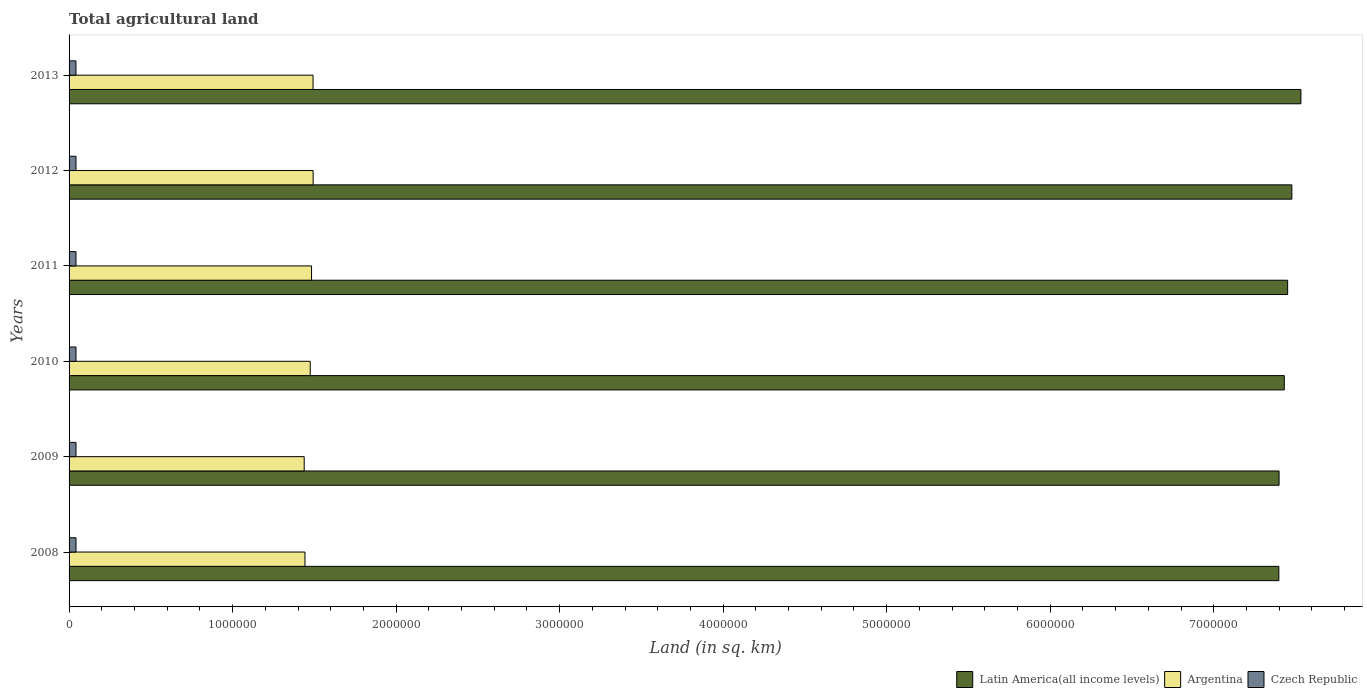How many bars are there on the 2nd tick from the bottom?
Offer a very short reply. 3. What is the label of the 6th group of bars from the top?
Give a very brief answer. 2008. What is the total agricultural land in Latin America(all income levels) in 2012?
Give a very brief answer. 7.48e+06. Across all years, what is the maximum total agricultural land in Argentina?
Provide a succinct answer. 1.49e+06. Across all years, what is the minimum total agricultural land in Latin America(all income levels)?
Ensure brevity in your answer.  7.40e+06. In which year was the total agricultural land in Argentina minimum?
Ensure brevity in your answer.  2009. What is the total total agricultural land in Argentina in the graph?
Offer a very short reply. 8.82e+06. What is the difference between the total agricultural land in Latin America(all income levels) in 2011 and that in 2012?
Give a very brief answer. -2.57e+04. What is the difference between the total agricultural land in Argentina in 2011 and the total agricultural land in Czech Republic in 2012?
Your answer should be very brief. 1.44e+06. What is the average total agricultural land in Latin America(all income levels) per year?
Provide a succinct answer. 7.45e+06. In the year 2008, what is the difference between the total agricultural land in Latin America(all income levels) and total agricultural land in Czech Republic?
Make the answer very short. 7.36e+06. In how many years, is the total agricultural land in Latin America(all income levels) greater than 4400000 sq.km?
Make the answer very short. 6. What is the ratio of the total agricultural land in Latin America(all income levels) in 2009 to that in 2010?
Ensure brevity in your answer.  1. What is the difference between the highest and the second highest total agricultural land in Latin America(all income levels)?
Your response must be concise. 5.54e+04. What is the difference between the highest and the lowest total agricultural land in Argentina?
Your answer should be compact. 5.46e+04. Is the sum of the total agricultural land in Latin America(all income levels) in 2009 and 2011 greater than the maximum total agricultural land in Argentina across all years?
Your response must be concise. Yes. What does the 3rd bar from the top in 2010 represents?
Provide a short and direct response. Latin America(all income levels). What does the 1st bar from the bottom in 2008 represents?
Provide a short and direct response. Latin America(all income levels). Is it the case that in every year, the sum of the total agricultural land in Czech Republic and total agricultural land in Latin America(all income levels) is greater than the total agricultural land in Argentina?
Your answer should be very brief. Yes. Are the values on the major ticks of X-axis written in scientific E-notation?
Keep it short and to the point. No. Does the graph contain grids?
Provide a short and direct response. No. Where does the legend appear in the graph?
Your response must be concise. Bottom right. How many legend labels are there?
Offer a very short reply. 3. How are the legend labels stacked?
Your answer should be compact. Horizontal. What is the title of the graph?
Offer a very short reply. Total agricultural land. Does "Ghana" appear as one of the legend labels in the graph?
Offer a very short reply. No. What is the label or title of the X-axis?
Ensure brevity in your answer.  Land (in sq. km). What is the label or title of the Y-axis?
Make the answer very short. Years. What is the Land (in sq. km) in Latin America(all income levels) in 2008?
Your answer should be very brief. 7.40e+06. What is the Land (in sq. km) of Argentina in 2008?
Make the answer very short. 1.44e+06. What is the Land (in sq. km) of Czech Republic in 2008?
Offer a very short reply. 4.24e+04. What is the Land (in sq. km) of Latin America(all income levels) in 2009?
Offer a very short reply. 7.40e+06. What is the Land (in sq. km) of Argentina in 2009?
Make the answer very short. 1.44e+06. What is the Land (in sq. km) in Czech Republic in 2009?
Your answer should be compact. 4.24e+04. What is the Land (in sq. km) in Latin America(all income levels) in 2010?
Offer a very short reply. 7.43e+06. What is the Land (in sq. km) of Argentina in 2010?
Offer a terse response. 1.47e+06. What is the Land (in sq. km) of Czech Republic in 2010?
Offer a very short reply. 4.23e+04. What is the Land (in sq. km) in Latin America(all income levels) in 2011?
Give a very brief answer. 7.45e+06. What is the Land (in sq. km) in Argentina in 2011?
Make the answer very short. 1.48e+06. What is the Land (in sq. km) of Czech Republic in 2011?
Give a very brief answer. 4.23e+04. What is the Land (in sq. km) in Latin America(all income levels) in 2012?
Offer a very short reply. 7.48e+06. What is the Land (in sq. km) in Argentina in 2012?
Offer a very short reply. 1.49e+06. What is the Land (in sq. km) in Czech Republic in 2012?
Provide a succinct answer. 4.22e+04. What is the Land (in sq. km) in Latin America(all income levels) in 2013?
Offer a very short reply. 7.53e+06. What is the Land (in sq. km) of Argentina in 2013?
Ensure brevity in your answer.  1.49e+06. What is the Land (in sq. km) in Czech Republic in 2013?
Your response must be concise. 4.22e+04. Across all years, what is the maximum Land (in sq. km) of Latin America(all income levels)?
Your response must be concise. 7.53e+06. Across all years, what is the maximum Land (in sq. km) of Argentina?
Offer a terse response. 1.49e+06. Across all years, what is the maximum Land (in sq. km) of Czech Republic?
Provide a succinct answer. 4.24e+04. Across all years, what is the minimum Land (in sq. km) of Latin America(all income levels)?
Keep it short and to the point. 7.40e+06. Across all years, what is the minimum Land (in sq. km) of Argentina?
Your answer should be very brief. 1.44e+06. Across all years, what is the minimum Land (in sq. km) in Czech Republic?
Provide a succinct answer. 4.22e+04. What is the total Land (in sq. km) in Latin America(all income levels) in the graph?
Your answer should be very brief. 4.47e+07. What is the total Land (in sq. km) in Argentina in the graph?
Make the answer very short. 8.82e+06. What is the total Land (in sq. km) in Czech Republic in the graph?
Keep it short and to the point. 2.54e+05. What is the difference between the Land (in sq. km) of Latin America(all income levels) in 2008 and that in 2009?
Ensure brevity in your answer.  -1397.7. What is the difference between the Land (in sq. km) of Argentina in 2008 and that in 2009?
Make the answer very short. 4690. What is the difference between the Land (in sq. km) of Czech Republic in 2008 and that in 2009?
Provide a short and direct response. 50. What is the difference between the Land (in sq. km) of Latin America(all income levels) in 2008 and that in 2010?
Offer a very short reply. -3.33e+04. What is the difference between the Land (in sq. km) of Argentina in 2008 and that in 2010?
Provide a succinct answer. -3.22e+04. What is the difference between the Land (in sq. km) in Latin America(all income levels) in 2008 and that in 2011?
Your answer should be compact. -5.38e+04. What is the difference between the Land (in sq. km) in Argentina in 2008 and that in 2011?
Provide a short and direct response. -4.02e+04. What is the difference between the Land (in sq. km) of Czech Republic in 2008 and that in 2011?
Your answer should be compact. 150. What is the difference between the Land (in sq. km) in Latin America(all income levels) in 2008 and that in 2012?
Offer a terse response. -7.95e+04. What is the difference between the Land (in sq. km) in Argentina in 2008 and that in 2012?
Your answer should be very brief. -4.99e+04. What is the difference between the Land (in sq. km) in Czech Republic in 2008 and that in 2012?
Your answer should be compact. 190. What is the difference between the Land (in sq. km) in Latin America(all income levels) in 2008 and that in 2013?
Provide a succinct answer. -1.35e+05. What is the difference between the Land (in sq. km) in Argentina in 2008 and that in 2013?
Your answer should be compact. -4.94e+04. What is the difference between the Land (in sq. km) of Czech Republic in 2008 and that in 2013?
Your answer should be very brief. 250. What is the difference between the Land (in sq. km) in Latin America(all income levels) in 2009 and that in 2010?
Give a very brief answer. -3.19e+04. What is the difference between the Land (in sq. km) in Argentina in 2009 and that in 2010?
Your answer should be compact. -3.69e+04. What is the difference between the Land (in sq. km) of Latin America(all income levels) in 2009 and that in 2011?
Provide a short and direct response. -5.24e+04. What is the difference between the Land (in sq. km) in Argentina in 2009 and that in 2011?
Give a very brief answer. -4.49e+04. What is the difference between the Land (in sq. km) of Czech Republic in 2009 and that in 2011?
Provide a short and direct response. 100. What is the difference between the Land (in sq. km) in Latin America(all income levels) in 2009 and that in 2012?
Your answer should be compact. -7.81e+04. What is the difference between the Land (in sq. km) of Argentina in 2009 and that in 2012?
Your response must be concise. -5.46e+04. What is the difference between the Land (in sq. km) in Czech Republic in 2009 and that in 2012?
Make the answer very short. 140. What is the difference between the Land (in sq. km) of Latin America(all income levels) in 2009 and that in 2013?
Your answer should be compact. -1.33e+05. What is the difference between the Land (in sq. km) in Argentina in 2009 and that in 2013?
Provide a succinct answer. -5.41e+04. What is the difference between the Land (in sq. km) of Czech Republic in 2009 and that in 2013?
Your answer should be very brief. 200. What is the difference between the Land (in sq. km) in Latin America(all income levels) in 2010 and that in 2011?
Keep it short and to the point. -2.05e+04. What is the difference between the Land (in sq. km) of Argentina in 2010 and that in 2011?
Offer a very short reply. -8000. What is the difference between the Land (in sq. km) of Czech Republic in 2010 and that in 2011?
Provide a short and direct response. 50. What is the difference between the Land (in sq. km) of Latin America(all income levels) in 2010 and that in 2012?
Your answer should be compact. -4.62e+04. What is the difference between the Land (in sq. km) of Argentina in 2010 and that in 2012?
Ensure brevity in your answer.  -1.77e+04. What is the difference between the Land (in sq. km) in Czech Republic in 2010 and that in 2012?
Offer a terse response. 90. What is the difference between the Land (in sq. km) of Latin America(all income levels) in 2010 and that in 2013?
Provide a succinct answer. -1.02e+05. What is the difference between the Land (in sq. km) in Argentina in 2010 and that in 2013?
Your answer should be very brief. -1.72e+04. What is the difference between the Land (in sq. km) of Czech Republic in 2010 and that in 2013?
Your answer should be very brief. 150. What is the difference between the Land (in sq. km) of Latin America(all income levels) in 2011 and that in 2012?
Offer a very short reply. -2.57e+04. What is the difference between the Land (in sq. km) of Argentina in 2011 and that in 2012?
Ensure brevity in your answer.  -9730. What is the difference between the Land (in sq. km) in Latin America(all income levels) in 2011 and that in 2013?
Offer a terse response. -8.11e+04. What is the difference between the Land (in sq. km) of Argentina in 2011 and that in 2013?
Give a very brief answer. -9180. What is the difference between the Land (in sq. km) of Czech Republic in 2011 and that in 2013?
Give a very brief answer. 100. What is the difference between the Land (in sq. km) in Latin America(all income levels) in 2012 and that in 2013?
Make the answer very short. -5.54e+04. What is the difference between the Land (in sq. km) in Argentina in 2012 and that in 2013?
Provide a short and direct response. 550. What is the difference between the Land (in sq. km) of Latin America(all income levels) in 2008 and the Land (in sq. km) of Argentina in 2009?
Offer a terse response. 5.96e+06. What is the difference between the Land (in sq. km) in Latin America(all income levels) in 2008 and the Land (in sq. km) in Czech Republic in 2009?
Give a very brief answer. 7.36e+06. What is the difference between the Land (in sq. km) in Argentina in 2008 and the Land (in sq. km) in Czech Republic in 2009?
Offer a very short reply. 1.40e+06. What is the difference between the Land (in sq. km) in Latin America(all income levels) in 2008 and the Land (in sq. km) in Argentina in 2010?
Your response must be concise. 5.92e+06. What is the difference between the Land (in sq. km) of Latin America(all income levels) in 2008 and the Land (in sq. km) of Czech Republic in 2010?
Provide a succinct answer. 7.36e+06. What is the difference between the Land (in sq. km) in Argentina in 2008 and the Land (in sq. km) in Czech Republic in 2010?
Provide a short and direct response. 1.40e+06. What is the difference between the Land (in sq. km) of Latin America(all income levels) in 2008 and the Land (in sq. km) of Argentina in 2011?
Your answer should be compact. 5.92e+06. What is the difference between the Land (in sq. km) in Latin America(all income levels) in 2008 and the Land (in sq. km) in Czech Republic in 2011?
Your answer should be very brief. 7.36e+06. What is the difference between the Land (in sq. km) in Argentina in 2008 and the Land (in sq. km) in Czech Republic in 2011?
Your answer should be very brief. 1.40e+06. What is the difference between the Land (in sq. km) in Latin America(all income levels) in 2008 and the Land (in sq. km) in Argentina in 2012?
Make the answer very short. 5.91e+06. What is the difference between the Land (in sq. km) of Latin America(all income levels) in 2008 and the Land (in sq. km) of Czech Republic in 2012?
Your response must be concise. 7.36e+06. What is the difference between the Land (in sq. km) of Argentina in 2008 and the Land (in sq. km) of Czech Republic in 2012?
Keep it short and to the point. 1.40e+06. What is the difference between the Land (in sq. km) of Latin America(all income levels) in 2008 and the Land (in sq. km) of Argentina in 2013?
Provide a succinct answer. 5.91e+06. What is the difference between the Land (in sq. km) in Latin America(all income levels) in 2008 and the Land (in sq. km) in Czech Republic in 2013?
Your answer should be compact. 7.36e+06. What is the difference between the Land (in sq. km) in Argentina in 2008 and the Land (in sq. km) in Czech Republic in 2013?
Your answer should be compact. 1.40e+06. What is the difference between the Land (in sq. km) of Latin America(all income levels) in 2009 and the Land (in sq. km) of Argentina in 2010?
Offer a terse response. 5.92e+06. What is the difference between the Land (in sq. km) of Latin America(all income levels) in 2009 and the Land (in sq. km) of Czech Republic in 2010?
Keep it short and to the point. 7.36e+06. What is the difference between the Land (in sq. km) in Argentina in 2009 and the Land (in sq. km) in Czech Republic in 2010?
Make the answer very short. 1.40e+06. What is the difference between the Land (in sq. km) of Latin America(all income levels) in 2009 and the Land (in sq. km) of Argentina in 2011?
Ensure brevity in your answer.  5.92e+06. What is the difference between the Land (in sq. km) in Latin America(all income levels) in 2009 and the Land (in sq. km) in Czech Republic in 2011?
Ensure brevity in your answer.  7.36e+06. What is the difference between the Land (in sq. km) of Argentina in 2009 and the Land (in sq. km) of Czech Republic in 2011?
Your answer should be compact. 1.40e+06. What is the difference between the Land (in sq. km) of Latin America(all income levels) in 2009 and the Land (in sq. km) of Argentina in 2012?
Ensure brevity in your answer.  5.91e+06. What is the difference between the Land (in sq. km) of Latin America(all income levels) in 2009 and the Land (in sq. km) of Czech Republic in 2012?
Your answer should be very brief. 7.36e+06. What is the difference between the Land (in sq. km) of Argentina in 2009 and the Land (in sq. km) of Czech Republic in 2012?
Your answer should be very brief. 1.40e+06. What is the difference between the Land (in sq. km) of Latin America(all income levels) in 2009 and the Land (in sq. km) of Argentina in 2013?
Your answer should be compact. 5.91e+06. What is the difference between the Land (in sq. km) of Latin America(all income levels) in 2009 and the Land (in sq. km) of Czech Republic in 2013?
Provide a succinct answer. 7.36e+06. What is the difference between the Land (in sq. km) of Argentina in 2009 and the Land (in sq. km) of Czech Republic in 2013?
Provide a succinct answer. 1.40e+06. What is the difference between the Land (in sq. km) in Latin America(all income levels) in 2010 and the Land (in sq. km) in Argentina in 2011?
Provide a short and direct response. 5.95e+06. What is the difference between the Land (in sq. km) of Latin America(all income levels) in 2010 and the Land (in sq. km) of Czech Republic in 2011?
Provide a short and direct response. 7.39e+06. What is the difference between the Land (in sq. km) in Argentina in 2010 and the Land (in sq. km) in Czech Republic in 2011?
Give a very brief answer. 1.43e+06. What is the difference between the Land (in sq. km) of Latin America(all income levels) in 2010 and the Land (in sq. km) of Argentina in 2012?
Your answer should be very brief. 5.94e+06. What is the difference between the Land (in sq. km) of Latin America(all income levels) in 2010 and the Land (in sq. km) of Czech Republic in 2012?
Your response must be concise. 7.39e+06. What is the difference between the Land (in sq. km) in Argentina in 2010 and the Land (in sq. km) in Czech Republic in 2012?
Your answer should be compact. 1.43e+06. What is the difference between the Land (in sq. km) of Latin America(all income levels) in 2010 and the Land (in sq. km) of Argentina in 2013?
Provide a short and direct response. 5.94e+06. What is the difference between the Land (in sq. km) of Latin America(all income levels) in 2010 and the Land (in sq. km) of Czech Republic in 2013?
Your response must be concise. 7.39e+06. What is the difference between the Land (in sq. km) in Argentina in 2010 and the Land (in sq. km) in Czech Republic in 2013?
Keep it short and to the point. 1.43e+06. What is the difference between the Land (in sq. km) in Latin America(all income levels) in 2011 and the Land (in sq. km) in Argentina in 2012?
Offer a very short reply. 5.96e+06. What is the difference between the Land (in sq. km) of Latin America(all income levels) in 2011 and the Land (in sq. km) of Czech Republic in 2012?
Provide a succinct answer. 7.41e+06. What is the difference between the Land (in sq. km) in Argentina in 2011 and the Land (in sq. km) in Czech Republic in 2012?
Make the answer very short. 1.44e+06. What is the difference between the Land (in sq. km) in Latin America(all income levels) in 2011 and the Land (in sq. km) in Argentina in 2013?
Provide a short and direct response. 5.96e+06. What is the difference between the Land (in sq. km) of Latin America(all income levels) in 2011 and the Land (in sq. km) of Czech Republic in 2013?
Keep it short and to the point. 7.41e+06. What is the difference between the Land (in sq. km) of Argentina in 2011 and the Land (in sq. km) of Czech Republic in 2013?
Offer a terse response. 1.44e+06. What is the difference between the Land (in sq. km) of Latin America(all income levels) in 2012 and the Land (in sq. km) of Argentina in 2013?
Offer a terse response. 5.99e+06. What is the difference between the Land (in sq. km) of Latin America(all income levels) in 2012 and the Land (in sq. km) of Czech Republic in 2013?
Ensure brevity in your answer.  7.44e+06. What is the difference between the Land (in sq. km) in Argentina in 2012 and the Land (in sq. km) in Czech Republic in 2013?
Provide a succinct answer. 1.45e+06. What is the average Land (in sq. km) of Latin America(all income levels) per year?
Give a very brief answer. 7.45e+06. What is the average Land (in sq. km) in Argentina per year?
Offer a terse response. 1.47e+06. What is the average Land (in sq. km) in Czech Republic per year?
Keep it short and to the point. 4.23e+04. In the year 2008, what is the difference between the Land (in sq. km) of Latin America(all income levels) and Land (in sq. km) of Argentina?
Provide a succinct answer. 5.96e+06. In the year 2008, what is the difference between the Land (in sq. km) of Latin America(all income levels) and Land (in sq. km) of Czech Republic?
Provide a succinct answer. 7.36e+06. In the year 2008, what is the difference between the Land (in sq. km) of Argentina and Land (in sq. km) of Czech Republic?
Give a very brief answer. 1.40e+06. In the year 2009, what is the difference between the Land (in sq. km) of Latin America(all income levels) and Land (in sq. km) of Argentina?
Keep it short and to the point. 5.96e+06. In the year 2009, what is the difference between the Land (in sq. km) of Latin America(all income levels) and Land (in sq. km) of Czech Republic?
Give a very brief answer. 7.36e+06. In the year 2009, what is the difference between the Land (in sq. km) of Argentina and Land (in sq. km) of Czech Republic?
Your response must be concise. 1.40e+06. In the year 2010, what is the difference between the Land (in sq. km) of Latin America(all income levels) and Land (in sq. km) of Argentina?
Offer a terse response. 5.96e+06. In the year 2010, what is the difference between the Land (in sq. km) of Latin America(all income levels) and Land (in sq. km) of Czech Republic?
Offer a very short reply. 7.39e+06. In the year 2010, what is the difference between the Land (in sq. km) in Argentina and Land (in sq. km) in Czech Republic?
Offer a very short reply. 1.43e+06. In the year 2011, what is the difference between the Land (in sq. km) in Latin America(all income levels) and Land (in sq. km) in Argentina?
Your answer should be compact. 5.97e+06. In the year 2011, what is the difference between the Land (in sq. km) of Latin America(all income levels) and Land (in sq. km) of Czech Republic?
Your answer should be compact. 7.41e+06. In the year 2011, what is the difference between the Land (in sq. km) of Argentina and Land (in sq. km) of Czech Republic?
Your answer should be very brief. 1.44e+06. In the year 2012, what is the difference between the Land (in sq. km) of Latin America(all income levels) and Land (in sq. km) of Argentina?
Offer a terse response. 5.99e+06. In the year 2012, what is the difference between the Land (in sq. km) of Latin America(all income levels) and Land (in sq. km) of Czech Republic?
Provide a succinct answer. 7.44e+06. In the year 2012, what is the difference between the Land (in sq. km) of Argentina and Land (in sq. km) of Czech Republic?
Provide a short and direct response. 1.45e+06. In the year 2013, what is the difference between the Land (in sq. km) in Latin America(all income levels) and Land (in sq. km) in Argentina?
Ensure brevity in your answer.  6.04e+06. In the year 2013, what is the difference between the Land (in sq. km) of Latin America(all income levels) and Land (in sq. km) of Czech Republic?
Your answer should be very brief. 7.49e+06. In the year 2013, what is the difference between the Land (in sq. km) of Argentina and Land (in sq. km) of Czech Republic?
Make the answer very short. 1.45e+06. What is the ratio of the Land (in sq. km) of Latin America(all income levels) in 2008 to that in 2009?
Your response must be concise. 1. What is the ratio of the Land (in sq. km) in Czech Republic in 2008 to that in 2009?
Keep it short and to the point. 1. What is the ratio of the Land (in sq. km) in Argentina in 2008 to that in 2010?
Keep it short and to the point. 0.98. What is the ratio of the Land (in sq. km) of Argentina in 2008 to that in 2011?
Offer a terse response. 0.97. What is the ratio of the Land (in sq. km) of Latin America(all income levels) in 2008 to that in 2012?
Provide a short and direct response. 0.99. What is the ratio of the Land (in sq. km) of Argentina in 2008 to that in 2012?
Keep it short and to the point. 0.97. What is the ratio of the Land (in sq. km) in Latin America(all income levels) in 2008 to that in 2013?
Ensure brevity in your answer.  0.98. What is the ratio of the Land (in sq. km) in Argentina in 2008 to that in 2013?
Ensure brevity in your answer.  0.97. What is the ratio of the Land (in sq. km) in Czech Republic in 2008 to that in 2013?
Offer a very short reply. 1.01. What is the ratio of the Land (in sq. km) of Argentina in 2009 to that in 2010?
Your answer should be compact. 0.97. What is the ratio of the Land (in sq. km) in Czech Republic in 2009 to that in 2010?
Ensure brevity in your answer.  1. What is the ratio of the Land (in sq. km) in Latin America(all income levels) in 2009 to that in 2011?
Your response must be concise. 0.99. What is the ratio of the Land (in sq. km) of Argentina in 2009 to that in 2011?
Offer a terse response. 0.97. What is the ratio of the Land (in sq. km) in Czech Republic in 2009 to that in 2011?
Give a very brief answer. 1. What is the ratio of the Land (in sq. km) of Latin America(all income levels) in 2009 to that in 2012?
Provide a succinct answer. 0.99. What is the ratio of the Land (in sq. km) in Argentina in 2009 to that in 2012?
Keep it short and to the point. 0.96. What is the ratio of the Land (in sq. km) in Latin America(all income levels) in 2009 to that in 2013?
Keep it short and to the point. 0.98. What is the ratio of the Land (in sq. km) in Argentina in 2009 to that in 2013?
Provide a succinct answer. 0.96. What is the ratio of the Land (in sq. km) in Latin America(all income levels) in 2010 to that in 2011?
Your response must be concise. 1. What is the ratio of the Land (in sq. km) of Czech Republic in 2010 to that in 2011?
Make the answer very short. 1. What is the ratio of the Land (in sq. km) in Latin America(all income levels) in 2010 to that in 2013?
Your answer should be very brief. 0.99. What is the ratio of the Land (in sq. km) of Czech Republic in 2010 to that in 2013?
Give a very brief answer. 1. What is the ratio of the Land (in sq. km) in Czech Republic in 2011 to that in 2012?
Make the answer very short. 1. What is the ratio of the Land (in sq. km) in Argentina in 2011 to that in 2013?
Ensure brevity in your answer.  0.99. What is the ratio of the Land (in sq. km) of Latin America(all income levels) in 2012 to that in 2013?
Keep it short and to the point. 0.99. What is the ratio of the Land (in sq. km) of Argentina in 2012 to that in 2013?
Your answer should be compact. 1. What is the ratio of the Land (in sq. km) in Czech Republic in 2012 to that in 2013?
Make the answer very short. 1. What is the difference between the highest and the second highest Land (in sq. km) of Latin America(all income levels)?
Offer a very short reply. 5.54e+04. What is the difference between the highest and the second highest Land (in sq. km) of Argentina?
Provide a short and direct response. 550. What is the difference between the highest and the lowest Land (in sq. km) of Latin America(all income levels)?
Offer a very short reply. 1.35e+05. What is the difference between the highest and the lowest Land (in sq. km) in Argentina?
Your answer should be very brief. 5.46e+04. What is the difference between the highest and the lowest Land (in sq. km) in Czech Republic?
Make the answer very short. 250. 